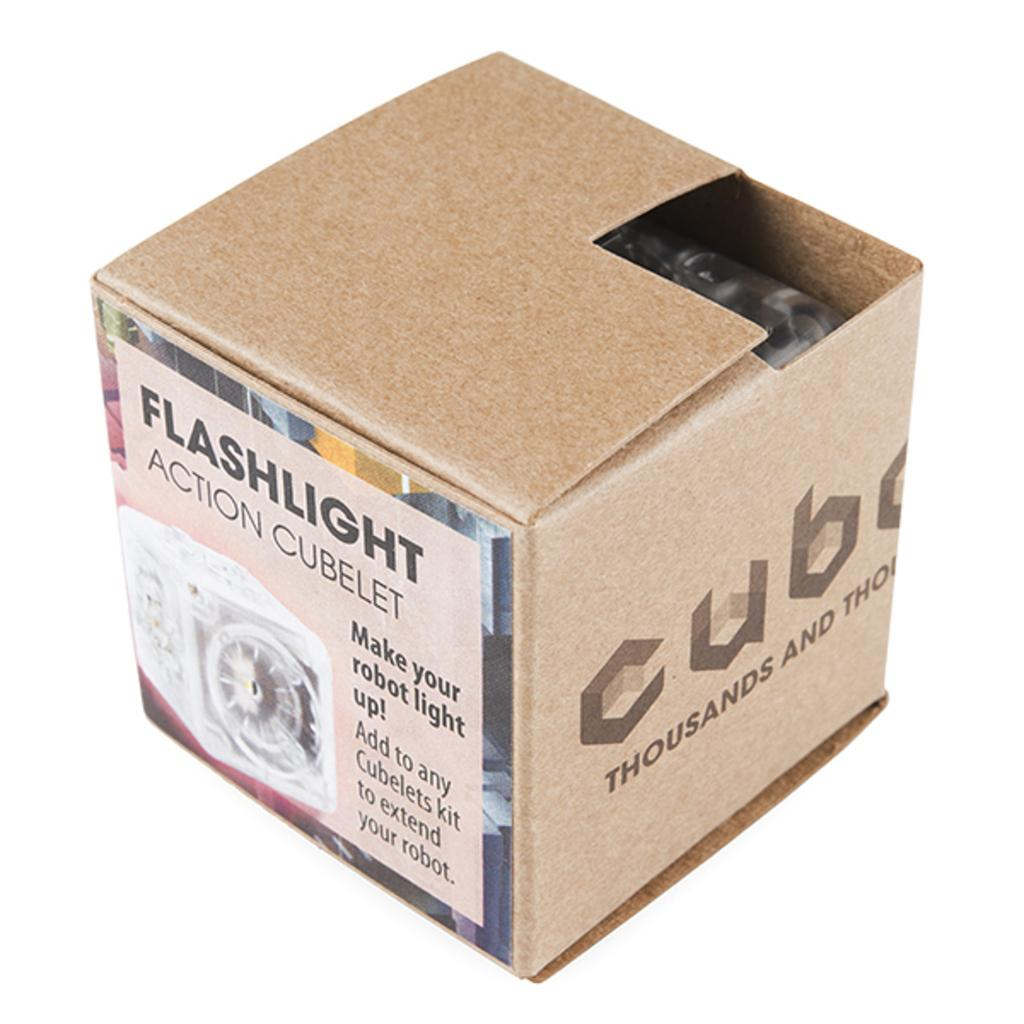Provide a one-sentence caption for the provided image. A box with a label for a flashlight on the side is partially open. 